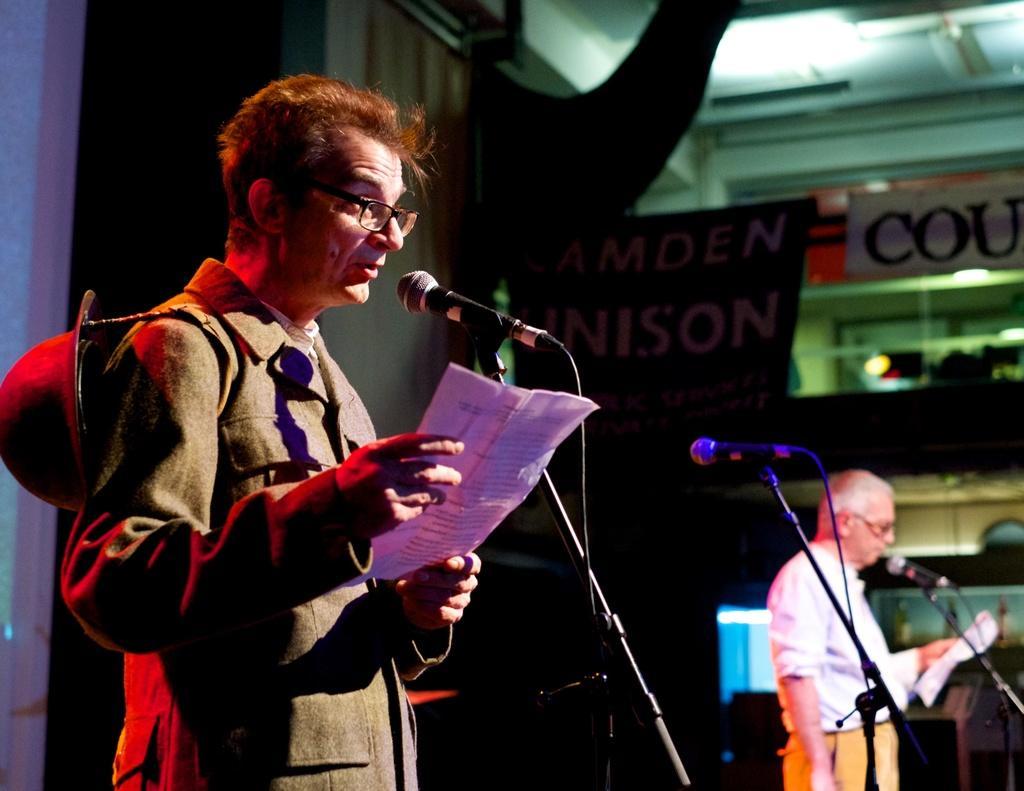Could you give a brief overview of what you see in this image? In this image, we can see two men are standing in-front of microphones and holding papers. Here we can see rods and wires. Background we can see wall, banners and few objects. On the right side and background we can see the blur view. 